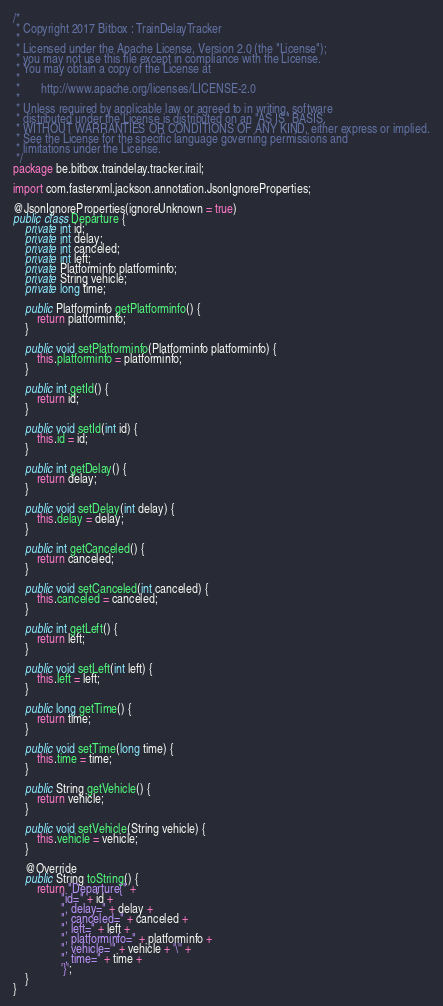<code> <loc_0><loc_0><loc_500><loc_500><_Java_>/*
 * Copyright 2017 Bitbox : TrainDelayTracker
 *
 * Licensed under the Apache License, Version 2.0 (the "License");
 * you may not use this file except in compliance with the License.
 * You may obtain a copy of the License at
 *
 *       http://www.apache.org/licenses/LICENSE-2.0
 *
 * Unless required by applicable law or agreed to in writing, software
 * distributed under the License is distributed on an "AS IS" BASIS,
 * WITHOUT WARRANTIES OR CONDITIONS OF ANY KIND, either express or implied.
 * See the License for the specific language governing permissions and
 * limitations under the License.
 */
package be.bitbox.traindelay.tracker.irail;

import com.fasterxml.jackson.annotation.JsonIgnoreProperties;

@JsonIgnoreProperties(ignoreUnknown = true)
public class Departure {
    private int id;
    private int delay;
    private int canceled;
    private int left;
    private Platforminfo platforminfo;
    private String vehicle;
    private long time;

    public Platforminfo getPlatforminfo() {
        return platforminfo;
    }

    public void setPlatforminfo(Platforminfo platforminfo) {
        this.platforminfo = platforminfo;
    }

    public int getId() {
        return id;
    }

    public void setId(int id) {
        this.id = id;
    }

    public int getDelay() {
        return delay;
    }

    public void setDelay(int delay) {
        this.delay = delay;
    }

    public int getCanceled() {
        return canceled;
    }

    public void setCanceled(int canceled) {
        this.canceled = canceled;
    }

    public int getLeft() {
        return left;
    }

    public void setLeft(int left) {
        this.left = left;
    }

    public long getTime() {
        return time;
    }

    public void setTime(long time) {
        this.time = time;
    }

    public String getVehicle() {
        return vehicle;
    }

    public void setVehicle(String vehicle) {
        this.vehicle = vehicle;
    }

    @Override
    public String toString() {
        return "Departure{" +
                "id=" + id +
                ", delay=" + delay +
                ", canceled=" + canceled +
                ", left=" + left +
                ", platforminfo=" + platforminfo +
                ", vehicle='" + vehicle + '\'' +
                ", time=" + time +
                '}';
    }
}
</code> 